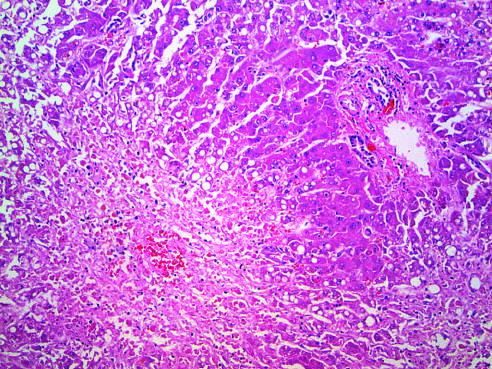s the cut surface indicated by the asterisk?
Answer the question using a single word or phrase. No 